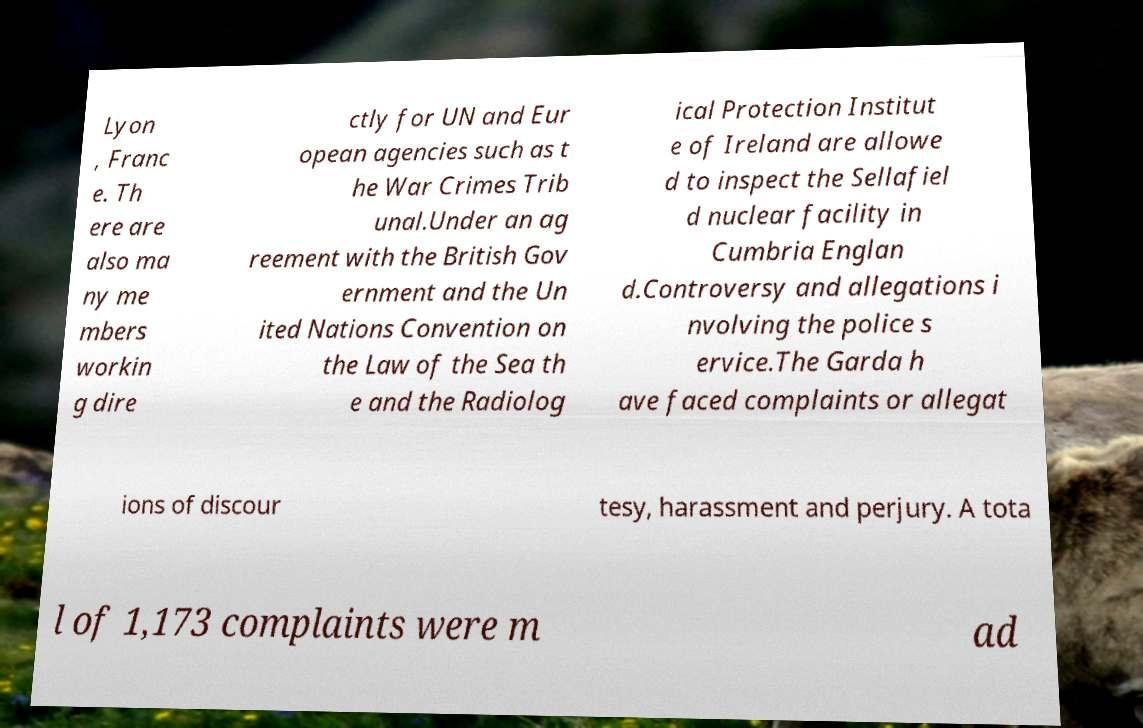There's text embedded in this image that I need extracted. Can you transcribe it verbatim? Lyon , Franc e. Th ere are also ma ny me mbers workin g dire ctly for UN and Eur opean agencies such as t he War Crimes Trib unal.Under an ag reement with the British Gov ernment and the Un ited Nations Convention on the Law of the Sea th e and the Radiolog ical Protection Institut e of Ireland are allowe d to inspect the Sellafiel d nuclear facility in Cumbria Englan d.Controversy and allegations i nvolving the police s ervice.The Garda h ave faced complaints or allegat ions of discour tesy, harassment and perjury. A tota l of 1,173 complaints were m ad 